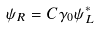Convert formula to latex. <formula><loc_0><loc_0><loc_500><loc_500>\psi _ { R } = C \gamma _ { 0 } \psi _ { L } ^ { * }</formula> 